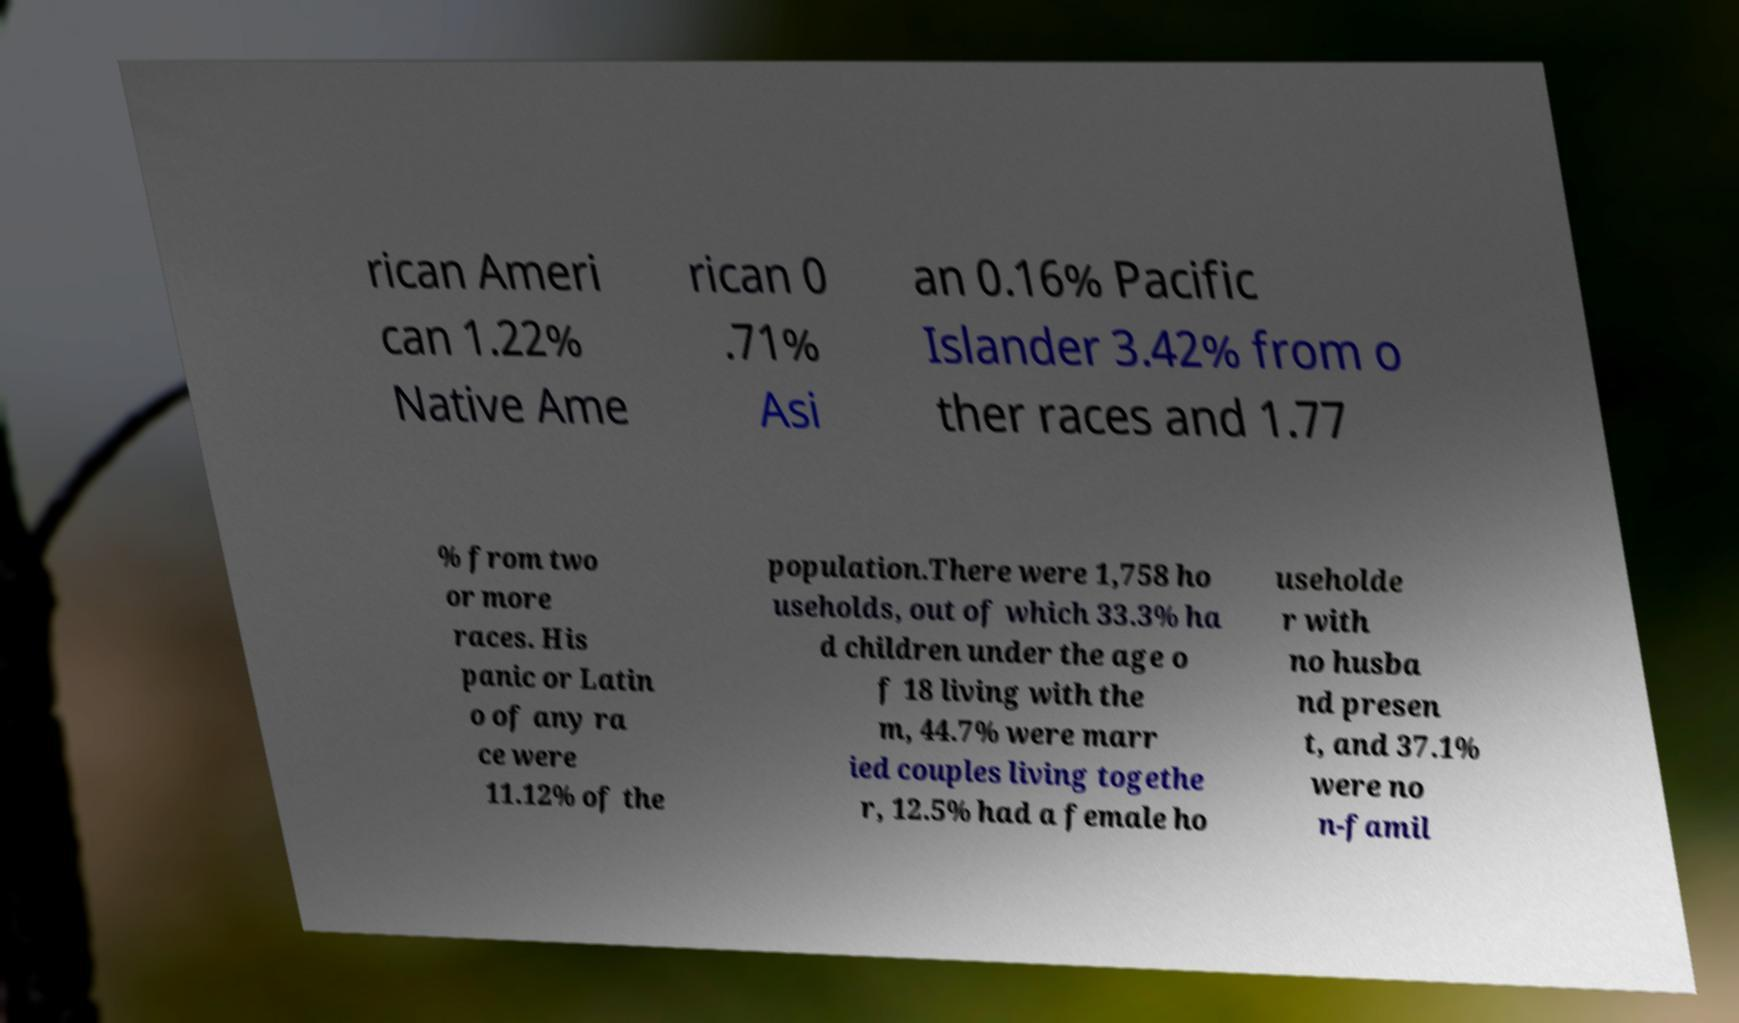What messages or text are displayed in this image? I need them in a readable, typed format. rican Ameri can 1.22% Native Ame rican 0 .71% Asi an 0.16% Pacific Islander 3.42% from o ther races and 1.77 % from two or more races. His panic or Latin o of any ra ce were 11.12% of the population.There were 1,758 ho useholds, out of which 33.3% ha d children under the age o f 18 living with the m, 44.7% were marr ied couples living togethe r, 12.5% had a female ho useholde r with no husba nd presen t, and 37.1% were no n-famil 